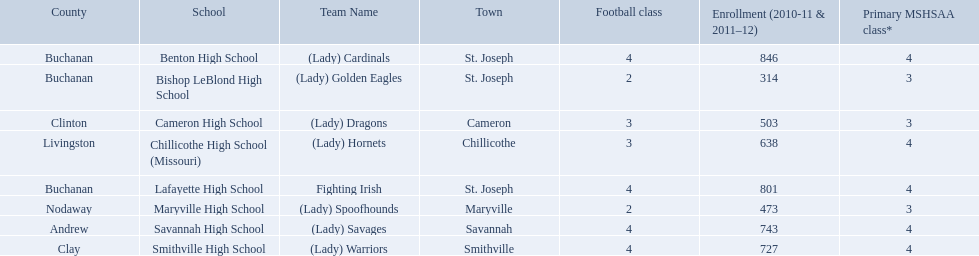What school in midland empire conference has 846 students enrolled? Benton High School. What school has 314 students enrolled? Bishop LeBlond High School. What school had 638 students enrolled? Chillicothe High School (Missouri). What were the schools enrolled in 2010-2011 Benton High School, Bishop LeBlond High School, Cameron High School, Chillicothe High School (Missouri), Lafayette High School, Maryville High School, Savannah High School, Smithville High School. How many were enrolled in each? 846, 314, 503, 638, 801, 473, 743, 727. Which is the lowest number? 314. Can you give me this table as a dict? {'header': ['County', 'School', 'Team Name', 'Town', 'Football class', 'Enrollment (2010-11 & 2011–12)', 'Primary MSHSAA class*'], 'rows': [['Buchanan', 'Benton High School', '(Lady) Cardinals', 'St. Joseph', '4', '846', '4'], ['Buchanan', 'Bishop LeBlond High School', '(Lady) Golden Eagles', 'St. Joseph', '2', '314', '3'], ['Clinton', 'Cameron High School', '(Lady) Dragons', 'Cameron', '3', '503', '3'], ['Livingston', 'Chillicothe High School (Missouri)', '(Lady) Hornets', 'Chillicothe', '3', '638', '4'], ['Buchanan', 'Lafayette High School', 'Fighting Irish', 'St. Joseph', '4', '801', '4'], ['Nodaway', 'Maryville High School', '(Lady) Spoofhounds', 'Maryville', '2', '473', '3'], ['Andrew', 'Savannah High School', '(Lady) Savages', 'Savannah', '4', '743', '4'], ['Clay', 'Smithville High School', '(Lady) Warriors', 'Smithville', '4', '727', '4']]} Which school had this number of students? Bishop LeBlond High School. 